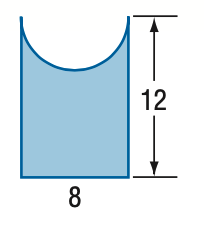Answer the mathemtical geometry problem and directly provide the correct option letter.
Question: Find the area of the figure. Round to the nearest tenth if necessary.
Choices: A: 45.7 B: 70.9 C: 83.4 D: 96 B 